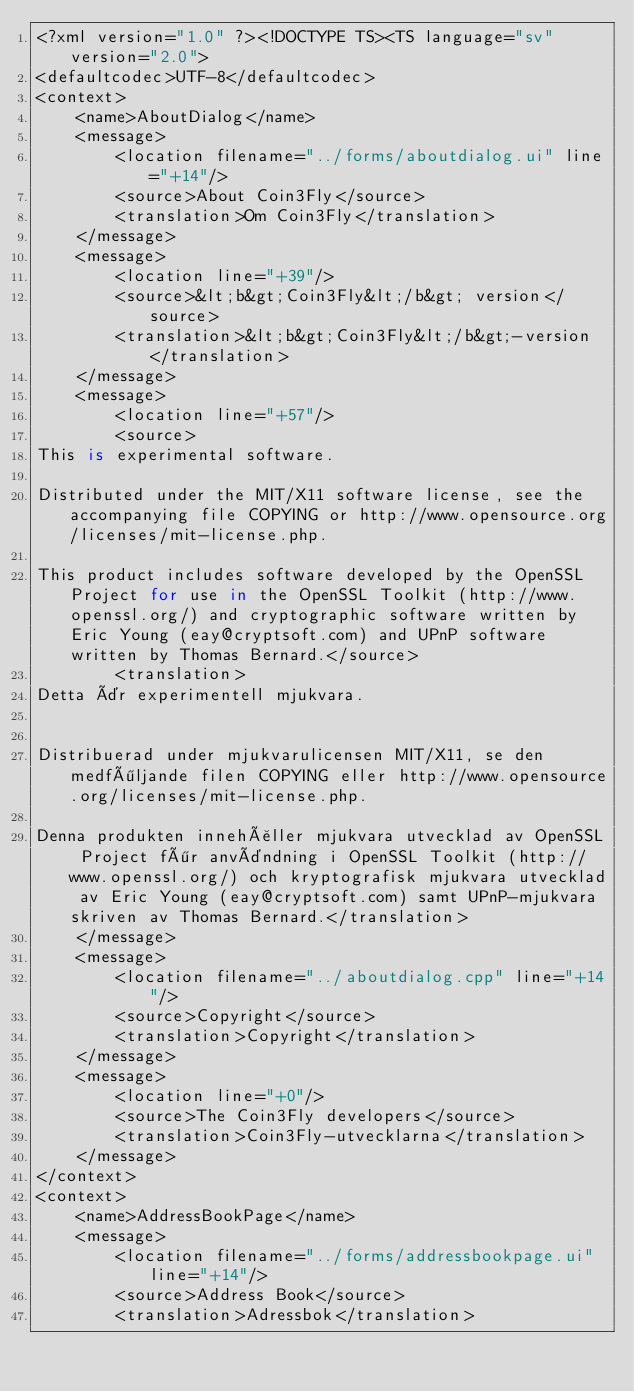Convert code to text. <code><loc_0><loc_0><loc_500><loc_500><_TypeScript_><?xml version="1.0" ?><!DOCTYPE TS><TS language="sv" version="2.0">
<defaultcodec>UTF-8</defaultcodec>
<context>
    <name>AboutDialog</name>
    <message>
        <location filename="../forms/aboutdialog.ui" line="+14"/>
        <source>About Coin3Fly</source>
        <translation>Om Coin3Fly</translation>
    </message>
    <message>
        <location line="+39"/>
        <source>&lt;b&gt;Coin3Fly&lt;/b&gt; version</source>
        <translation>&lt;b&gt;Coin3Fly&lt;/b&gt;-version</translation>
    </message>
    <message>
        <location line="+57"/>
        <source>
This is experimental software.

Distributed under the MIT/X11 software license, see the accompanying file COPYING or http://www.opensource.org/licenses/mit-license.php.

This product includes software developed by the OpenSSL Project for use in the OpenSSL Toolkit (http://www.openssl.org/) and cryptographic software written by Eric Young (eay@cryptsoft.com) and UPnP software written by Thomas Bernard.</source>
        <translation>
Detta är experimentell mjukvara.


Distribuerad under mjukvarulicensen MIT/X11, se den medföljande filen COPYING eller http://www.opensource.org/licenses/mit-license.php.

Denna produkten innehåller mjukvara utvecklad av OpenSSL Project för användning i OpenSSL Toolkit (http://www.openssl.org/) och kryptografisk mjukvara utvecklad av Eric Young (eay@cryptsoft.com) samt UPnP-mjukvara skriven av Thomas Bernard.</translation>
    </message>
    <message>
        <location filename="../aboutdialog.cpp" line="+14"/>
        <source>Copyright</source>
        <translation>Copyright</translation>
    </message>
    <message>
        <location line="+0"/>
        <source>The Coin3Fly developers</source>
        <translation>Coin3Fly-utvecklarna</translation>
    </message>
</context>
<context>
    <name>AddressBookPage</name>
    <message>
        <location filename="../forms/addressbookpage.ui" line="+14"/>
        <source>Address Book</source>
        <translation>Adressbok</translation></code> 